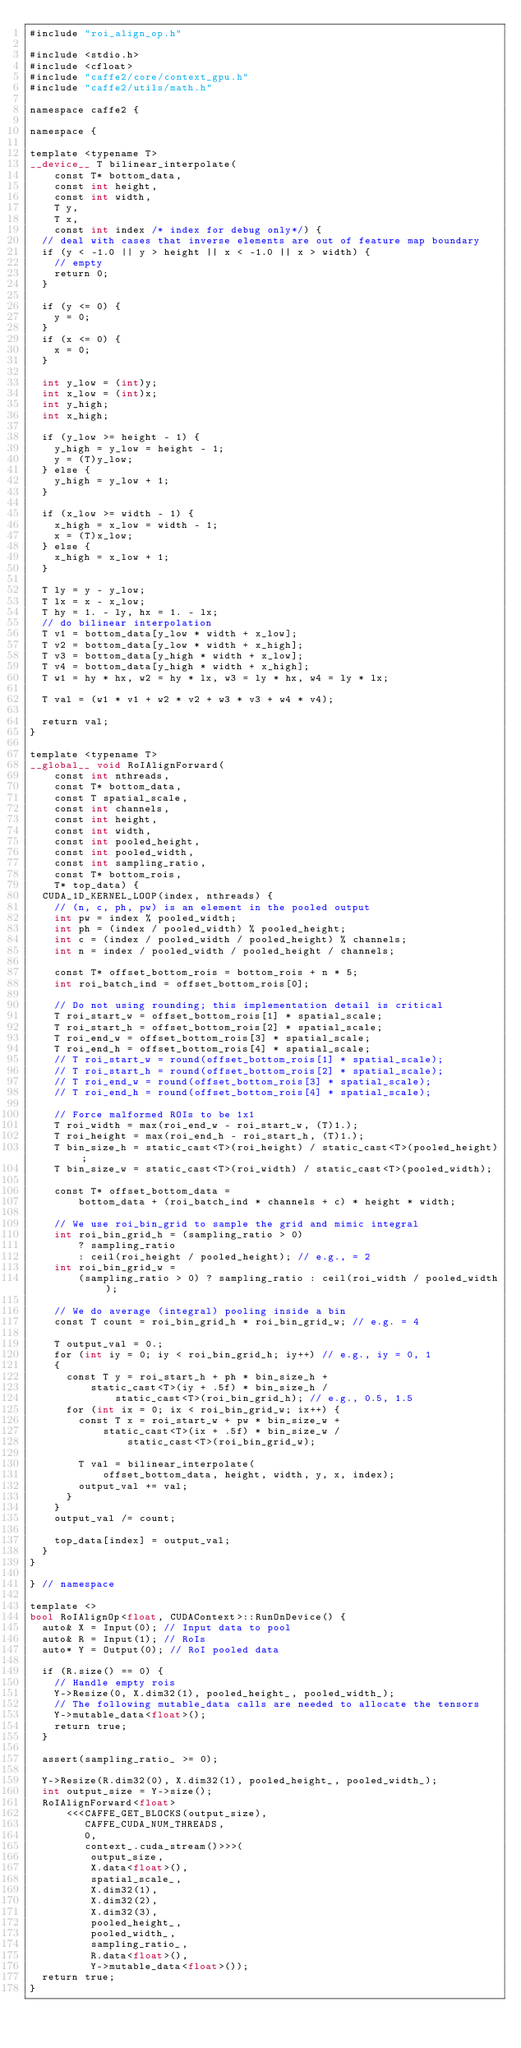Convert code to text. <code><loc_0><loc_0><loc_500><loc_500><_Cuda_>#include "roi_align_op.h"

#include <stdio.h>
#include <cfloat>
#include "caffe2/core/context_gpu.h"
#include "caffe2/utils/math.h"

namespace caffe2 {

namespace {

template <typename T>
__device__ T bilinear_interpolate(
    const T* bottom_data,
    const int height,
    const int width,
    T y,
    T x,
    const int index /* index for debug only*/) {
  // deal with cases that inverse elements are out of feature map boundary
  if (y < -1.0 || y > height || x < -1.0 || x > width) {
    // empty
    return 0;
  }

  if (y <= 0) {
    y = 0;
  }
  if (x <= 0) {
    x = 0;
  }

  int y_low = (int)y;
  int x_low = (int)x;
  int y_high;
  int x_high;

  if (y_low >= height - 1) {
    y_high = y_low = height - 1;
    y = (T)y_low;
  } else {
    y_high = y_low + 1;
  }

  if (x_low >= width - 1) {
    x_high = x_low = width - 1;
    x = (T)x_low;
  } else {
    x_high = x_low + 1;
  }

  T ly = y - y_low;
  T lx = x - x_low;
  T hy = 1. - ly, hx = 1. - lx;
  // do bilinear interpolation
  T v1 = bottom_data[y_low * width + x_low];
  T v2 = bottom_data[y_low * width + x_high];
  T v3 = bottom_data[y_high * width + x_low];
  T v4 = bottom_data[y_high * width + x_high];
  T w1 = hy * hx, w2 = hy * lx, w3 = ly * hx, w4 = ly * lx;

  T val = (w1 * v1 + w2 * v2 + w3 * v3 + w4 * v4);

  return val;
}

template <typename T>
__global__ void RoIAlignForward(
    const int nthreads,
    const T* bottom_data,
    const T spatial_scale,
    const int channels,
    const int height,
    const int width,
    const int pooled_height,
    const int pooled_width,
    const int sampling_ratio,
    const T* bottom_rois,
    T* top_data) {
  CUDA_1D_KERNEL_LOOP(index, nthreads) {
    // (n, c, ph, pw) is an element in the pooled output
    int pw = index % pooled_width;
    int ph = (index / pooled_width) % pooled_height;
    int c = (index / pooled_width / pooled_height) % channels;
    int n = index / pooled_width / pooled_height / channels;

    const T* offset_bottom_rois = bottom_rois + n * 5;
    int roi_batch_ind = offset_bottom_rois[0];

    // Do not using rounding; this implementation detail is critical
    T roi_start_w = offset_bottom_rois[1] * spatial_scale;
    T roi_start_h = offset_bottom_rois[2] * spatial_scale;
    T roi_end_w = offset_bottom_rois[3] * spatial_scale;
    T roi_end_h = offset_bottom_rois[4] * spatial_scale;
    // T roi_start_w = round(offset_bottom_rois[1] * spatial_scale);
    // T roi_start_h = round(offset_bottom_rois[2] * spatial_scale);
    // T roi_end_w = round(offset_bottom_rois[3] * spatial_scale);
    // T roi_end_h = round(offset_bottom_rois[4] * spatial_scale);

    // Force malformed ROIs to be 1x1
    T roi_width = max(roi_end_w - roi_start_w, (T)1.);
    T roi_height = max(roi_end_h - roi_start_h, (T)1.);
    T bin_size_h = static_cast<T>(roi_height) / static_cast<T>(pooled_height);
    T bin_size_w = static_cast<T>(roi_width) / static_cast<T>(pooled_width);

    const T* offset_bottom_data =
        bottom_data + (roi_batch_ind * channels + c) * height * width;

    // We use roi_bin_grid to sample the grid and mimic integral
    int roi_bin_grid_h = (sampling_ratio > 0)
        ? sampling_ratio
        : ceil(roi_height / pooled_height); // e.g., = 2
    int roi_bin_grid_w =
        (sampling_ratio > 0) ? sampling_ratio : ceil(roi_width / pooled_width);

    // We do average (integral) pooling inside a bin
    const T count = roi_bin_grid_h * roi_bin_grid_w; // e.g. = 4

    T output_val = 0.;
    for (int iy = 0; iy < roi_bin_grid_h; iy++) // e.g., iy = 0, 1
    {
      const T y = roi_start_h + ph * bin_size_h +
          static_cast<T>(iy + .5f) * bin_size_h /
              static_cast<T>(roi_bin_grid_h); // e.g., 0.5, 1.5
      for (int ix = 0; ix < roi_bin_grid_w; ix++) {
        const T x = roi_start_w + pw * bin_size_w +
            static_cast<T>(ix + .5f) * bin_size_w /
                static_cast<T>(roi_bin_grid_w);

        T val = bilinear_interpolate(
            offset_bottom_data, height, width, y, x, index);
        output_val += val;
      }
    }
    output_val /= count;

    top_data[index] = output_val;
  }
}

} // namespace

template <>
bool RoIAlignOp<float, CUDAContext>::RunOnDevice() {
  auto& X = Input(0); // Input data to pool
  auto& R = Input(1); // RoIs
  auto* Y = Output(0); // RoI pooled data

  if (R.size() == 0) {
    // Handle empty rois
    Y->Resize(0, X.dim32(1), pooled_height_, pooled_width_);
    // The following mutable_data calls are needed to allocate the tensors
    Y->mutable_data<float>();
    return true;
  }

  assert(sampling_ratio_ >= 0);

  Y->Resize(R.dim32(0), X.dim32(1), pooled_height_, pooled_width_);
  int output_size = Y->size();
  RoIAlignForward<float>
      <<<CAFFE_GET_BLOCKS(output_size),
         CAFFE_CUDA_NUM_THREADS,
         0,
         context_.cuda_stream()>>>(
          output_size,
          X.data<float>(),
          spatial_scale_,
          X.dim32(1),
          X.dim32(2),
          X.dim32(3),
          pooled_height_,
          pooled_width_,
          sampling_ratio_,
          R.data<float>(),
          Y->mutable_data<float>());
  return true;
}
</code> 